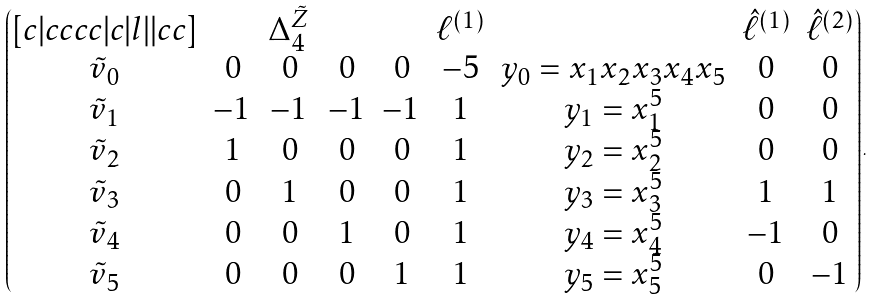Convert formula to latex. <formula><loc_0><loc_0><loc_500><loc_500>\begin{pmatrix} [ c | c c c c | c | l | | c c ] & & \Delta _ { 4 } ^ { \tilde { Z } } & & & \ell ^ { ( 1 ) } & & \hat { \ell } ^ { ( 1 ) } & \hat { \ell } ^ { ( 2 ) } \\ \tilde { v } _ { 0 } & 0 & 0 & 0 & 0 & - 5 & y _ { 0 } = x _ { 1 } x _ { 2 } x _ { 3 } x _ { 4 } x _ { 5 } & 0 & 0 \\ \tilde { v } _ { 1 } & - 1 & - 1 & - 1 & - 1 & 1 & y _ { 1 } = x _ { 1 } ^ { 5 } & 0 & 0 \\ \tilde { v } _ { 2 } & 1 & 0 & 0 & 0 & 1 & y _ { 2 } = x _ { 2 } ^ { 5 } & 0 & 0 \\ \tilde { v } _ { 3 } & 0 & 1 & 0 & 0 & 1 & y _ { 3 } = x _ { 3 } ^ { 5 } & 1 & 1 \\ \tilde { v } _ { 4 } & 0 & 0 & 1 & 0 & 1 & y _ { 4 } = x _ { 4 } ^ { 5 } & - 1 & 0 \\ \tilde { v } _ { 5 } & 0 & 0 & 0 & 1 & 1 & y _ { 5 } = x _ { 5 } ^ { 5 } & 0 & - 1 \end{pmatrix} .</formula> 